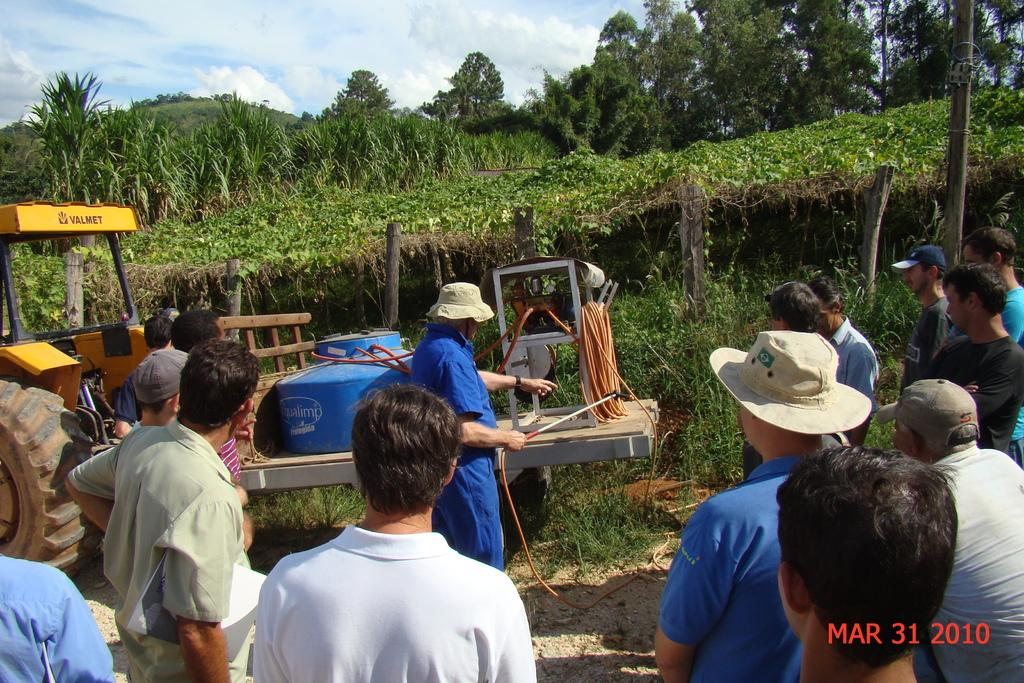What can be seen at the bottom of the image? There are people standing at the bottom of the image. What is located in the top left side of the image? There is a vehicle in the top left side of the image. What is behind the vehicle in the image? There are trees behind the vehicle. What is visible at the top of the image? There are clouds and sky visible at the top of the image. What type of cheese is being used to create friction between the people and the vehicle in the image? There is no cheese present in the image, and friction is not a factor in this context. What is the income level of the people standing at the bottom of the image? There is no information about the income level of the people in the image. 